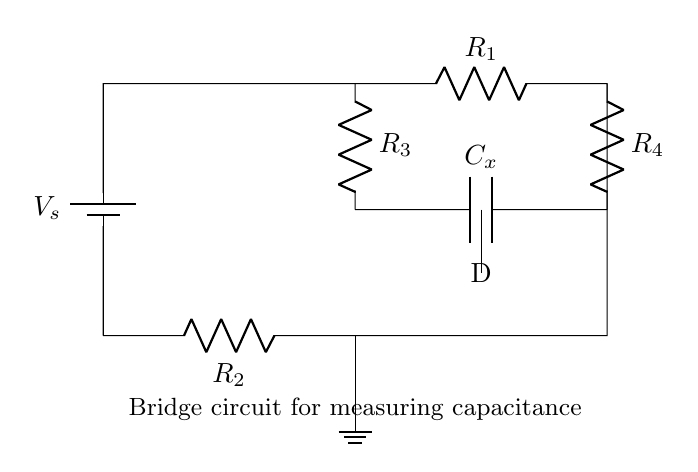What is the type of the circuit? The circuit is a bridge circuit specifically designed for measuring capacitance. Bridge circuits typically consist of multiple resistors and a capacitor arranged in a specific formation to balance the measurements.
Answer: bridge circuit What is the value of the capacitor being measured? The capacitor in the circuit is labeled as C_x, indicating that it is the unknown capacitor for measurement purposes. In bridge circuits, this symbol is commonly used to represent the capacitor whose value is to be determined.
Answer: C_x How many resistors are present in this circuit? There are four resistors in the circuit, labeled as R_1, R_2, R_3, and R_4. Counting each labeled component gives a total of four resistors.
Answer: four What role does the detector play in this circuit? The detector (labeled D) is used to assess the balance of the bridge. In a balanced bridge circuit, the detector indicates that there is no voltage difference, which helps to determine the value of the unknown capacitor.
Answer: balance measurement What is the configuration of the resistors in the circuit? The resistors are arranged in a bridge configuration, forming two voltage dividers with a capacitor bridging the gap. The arrangement allows for precise measurement by comparing the ratios of the resistances.
Answer: bridge configuration If the bridge is balanced, what does that imply about the capacitance? If the bridge is balanced, it implies that the ratio of the resistances corresponds to the value of the unknown capacitance, indicating that it can be calculated based on the known resistors.
Answer: calculated capacitance What is the purpose of the voltage source used in the circuit? The voltage source (labeled V_s) is essential for providing a potential difference across the circuit, powering the measurement and allowing the detection of voltage variations resulting from the capacitor's influence in the bridge.
Answer: provide potential difference 